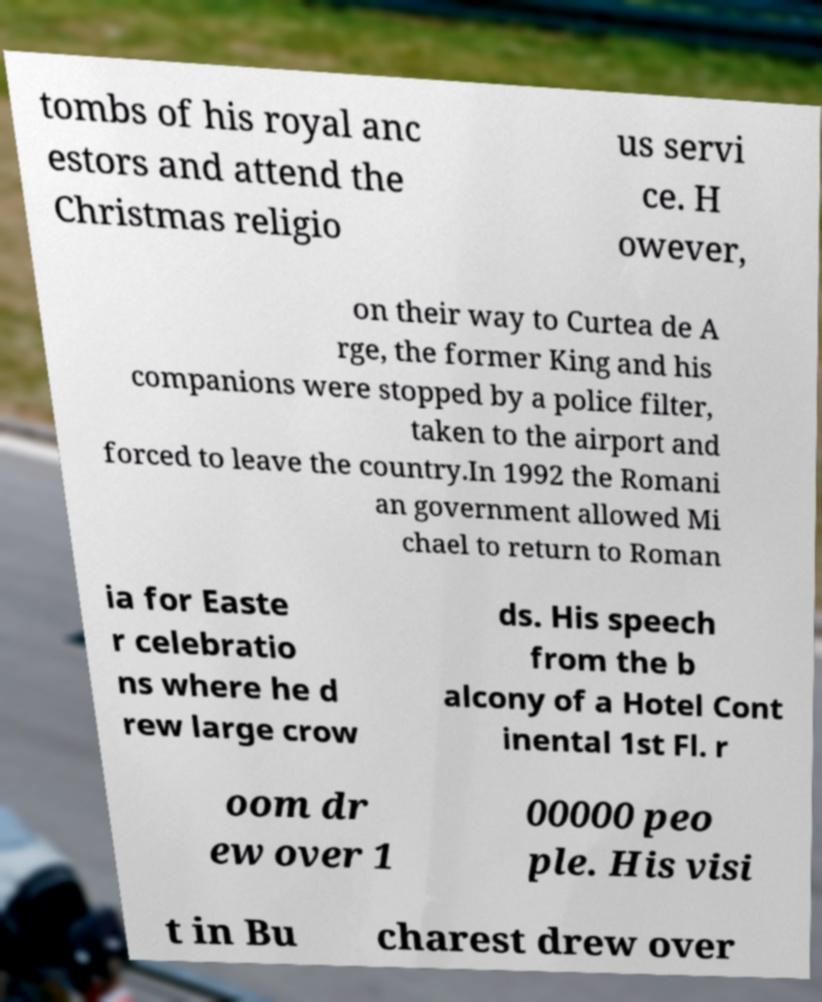Can you read and provide the text displayed in the image?This photo seems to have some interesting text. Can you extract and type it out for me? tombs of his royal anc estors and attend the Christmas religio us servi ce. H owever, on their way to Curtea de A rge, the former King and his companions were stopped by a police filter, taken to the airport and forced to leave the country.In 1992 the Romani an government allowed Mi chael to return to Roman ia for Easte r celebratio ns where he d rew large crow ds. His speech from the b alcony of a Hotel Cont inental 1st Fl. r oom dr ew over 1 00000 peo ple. His visi t in Bu charest drew over 